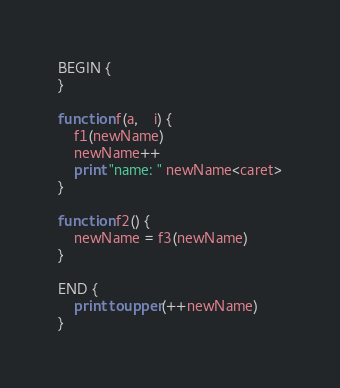Convert code to text. <code><loc_0><loc_0><loc_500><loc_500><_Awk_>BEGIN {
}

function f(a,    i) {
    f1(newName)
    newName++
    print "name: " newName<caret>
}

function f2() {
    newName = f3(newName)
}

END {
    print toupper(++newName)
}</code> 